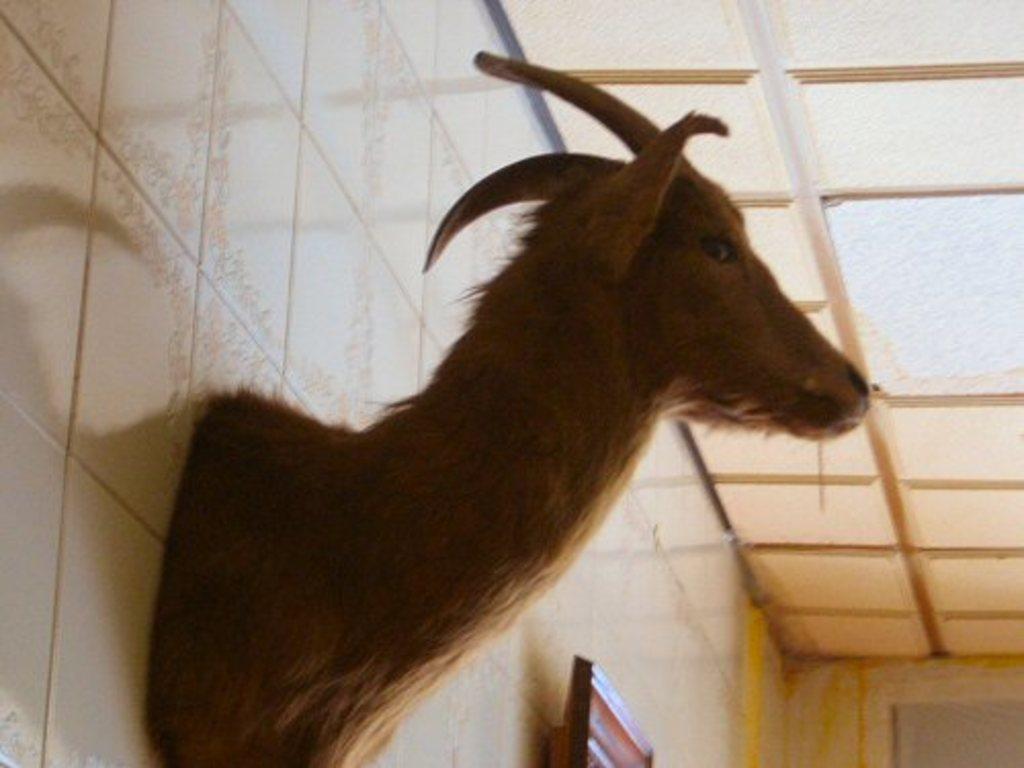Could you give a brief overview of what you see in this image? In the picture I can see the statue of a deer on the wall. It is looking like a television on the wall at the bottom of the picture. 